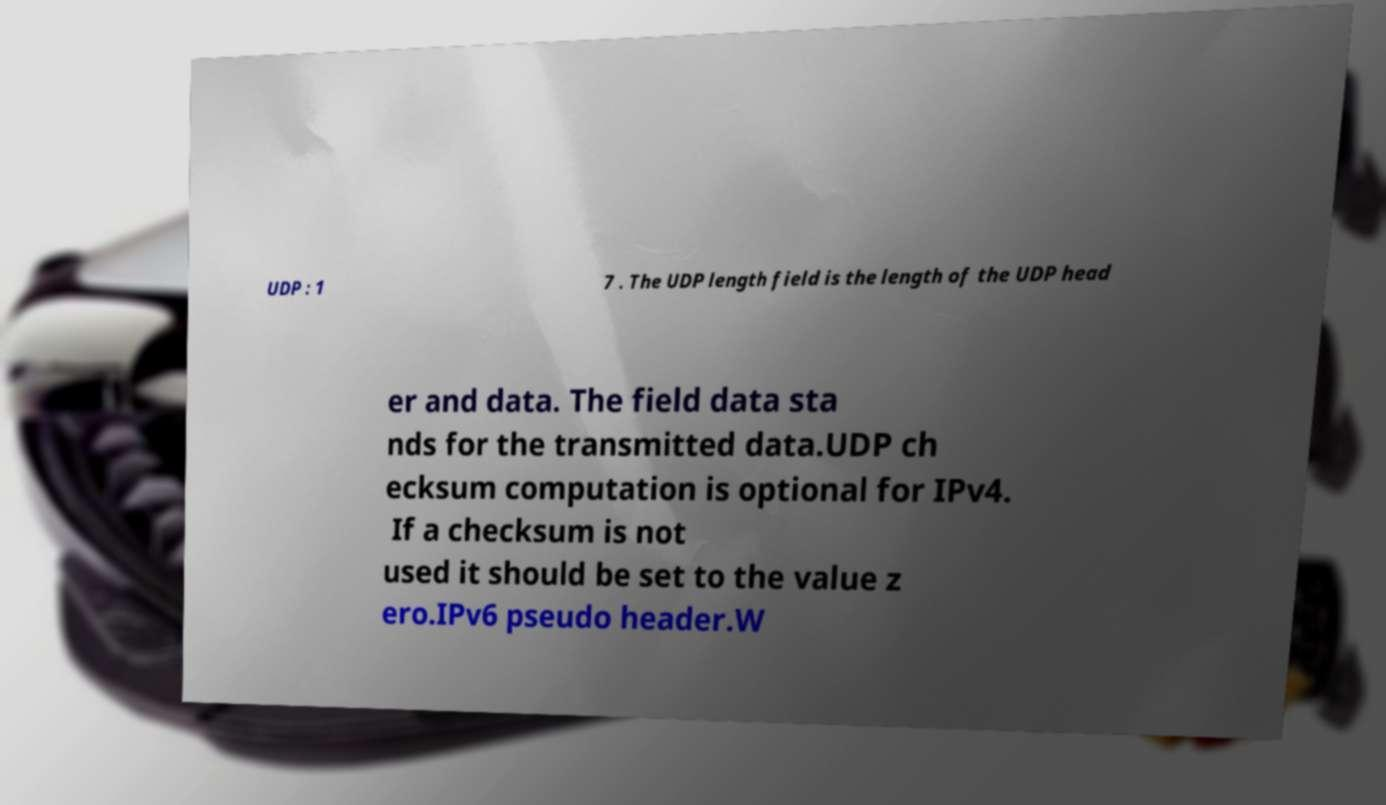Please read and relay the text visible in this image. What does it say? UDP : 1 7 . The UDP length field is the length of the UDP head er and data. The field data sta nds for the transmitted data.UDP ch ecksum computation is optional for IPv4. If a checksum is not used it should be set to the value z ero.IPv6 pseudo header.W 